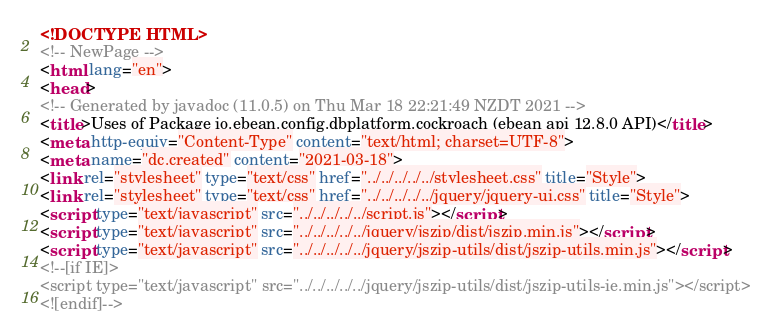Convert code to text. <code><loc_0><loc_0><loc_500><loc_500><_HTML_><!DOCTYPE HTML>
<!-- NewPage -->
<html lang="en">
<head>
<!-- Generated by javadoc (11.0.5) on Thu Mar 18 22:21:49 NZDT 2021 -->
<title>Uses of Package io.ebean.config.dbplatform.cockroach (ebean api 12.8.0 API)</title>
<meta http-equiv="Content-Type" content="text/html; charset=UTF-8">
<meta name="dc.created" content="2021-03-18">
<link rel="stylesheet" type="text/css" href="../../../../../stylesheet.css" title="Style">
<link rel="stylesheet" type="text/css" href="../../../../../jquery/jquery-ui.css" title="Style">
<script type="text/javascript" src="../../../../../script.js"></script>
<script type="text/javascript" src="../../../../../jquery/jszip/dist/jszip.min.js"></script>
<script type="text/javascript" src="../../../../../jquery/jszip-utils/dist/jszip-utils.min.js"></script>
<!--[if IE]>
<script type="text/javascript" src="../../../../../jquery/jszip-utils/dist/jszip-utils-ie.min.js"></script>
<![endif]--></code> 